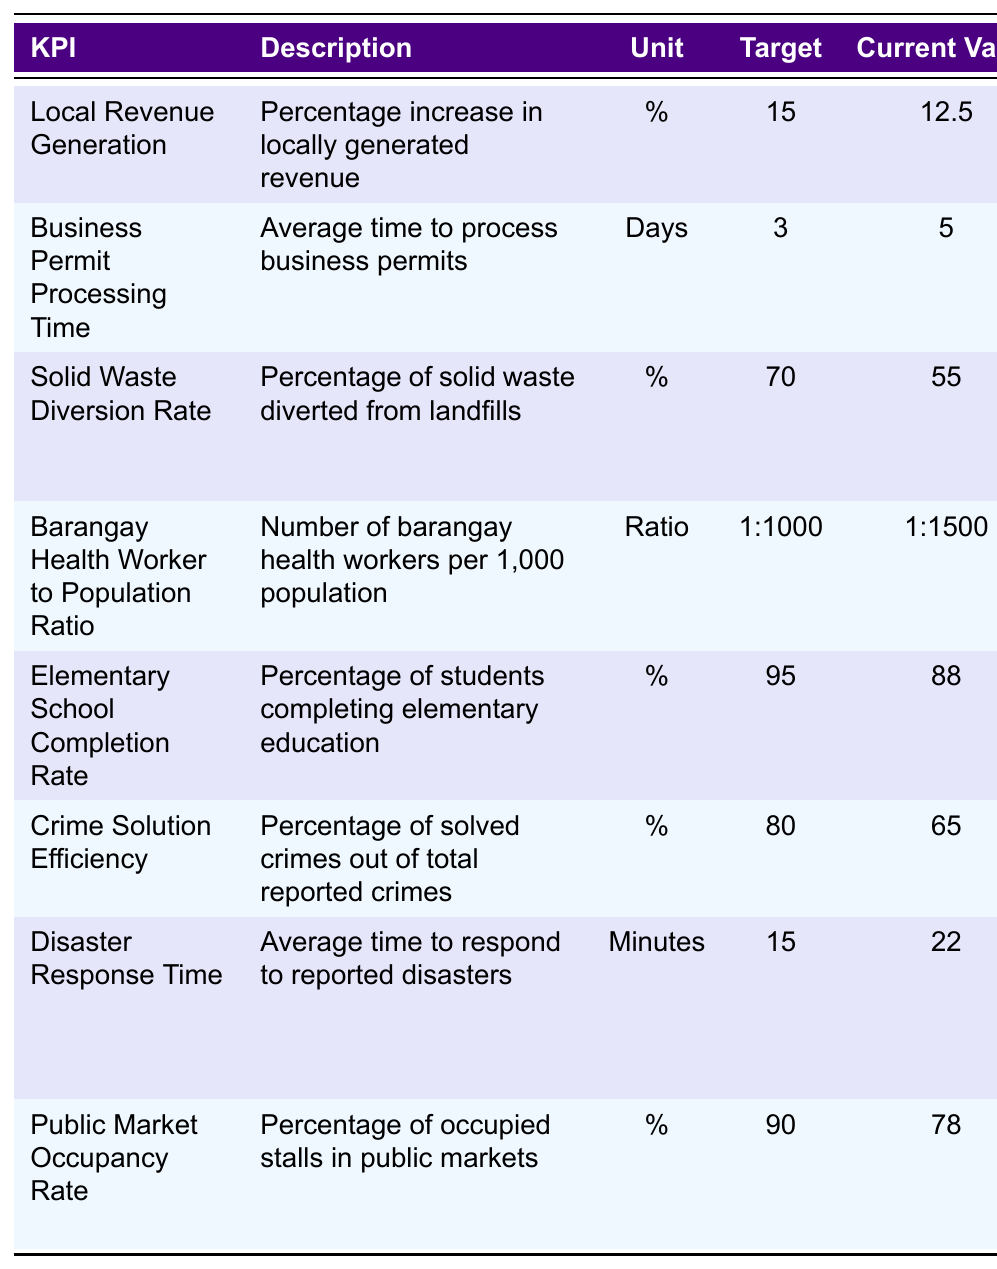What is the current value for Local Revenue Generation? The table lists the current value for Local Revenue Generation as 12.5%.
Answer: 12.5% Which KPI has the highest target value? The table shows various target values, with the highest being 95% for the Elementary School Completion Rate.
Answer: 95% Is the current value for Solid Waste Diversion Rate below its target? The current value for Solid Waste Diversion Rate is 55%, which is below the target of 70%.
Answer: Yes What is the average current value of the KPIs provided? To find the average, we sum up all current values: 12.5 + 5 + 55 + (1/1500)*1000 + 88 + 65 + (22/60)*1000 + 78. This gives us a value of approximately 295.5, and there are 8 KPIs. So the average is 295.5 / 8 = 36.94.
Answer: 36.94 Which KPI has the greatest shortfall from its target? To determine this, we calculate the difference between target and current values for each KPI. The greatest shortfall is for the Disaster Response Time with a difference of 7 minutes (15 - 22).
Answer: Disaster Response Time What is the ratio of Barangay Health Workers to the population? The table indicates a ratio of 1:1500 for Barangay Health Workers to the population.
Answer: 1:1500 Which department provides data for the Crime Solution Efficiency KPI? The table lists the Philippine National Police as the data source for Crime Solution Efficiency.
Answer: Philippine National Police Considering all KPIs, how many have current values below their targets? By reviewing the table, we find that Local Revenue Generation, Business Permit Processing Time, Solid Waste Diversion Rate, Barangay Health Worker to Population Ratio, Elementary School Completion Rate, Crime Solution Efficiency, Disaster Response Time, and Public Market Occupancy Rate, show that 6 of them are below their targets.
Answer: 6 What is the current value for Public Market Occupancy Rate, and how does it compare to its target? The current value for Public Market Occupancy Rate is 78%, which is below the target of 90%.
Answer: Below target If the current value for Disaster Response Time is subtracted from the target, what is the difference? The target for Disaster Response Time is 15 minutes, and the current value is 22 minutes. The difference is 15 - 22 = -7 minutes, indicating it's 7 minutes over the target.
Answer: -7 minutes 